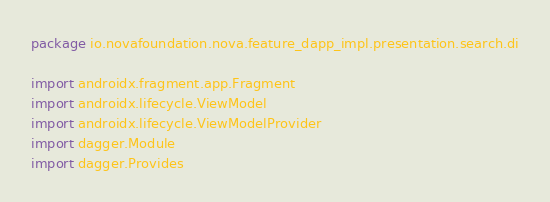<code> <loc_0><loc_0><loc_500><loc_500><_Kotlin_>package io.novafoundation.nova.feature_dapp_impl.presentation.search.di

import androidx.fragment.app.Fragment
import androidx.lifecycle.ViewModel
import androidx.lifecycle.ViewModelProvider
import dagger.Module
import dagger.Provides</code> 